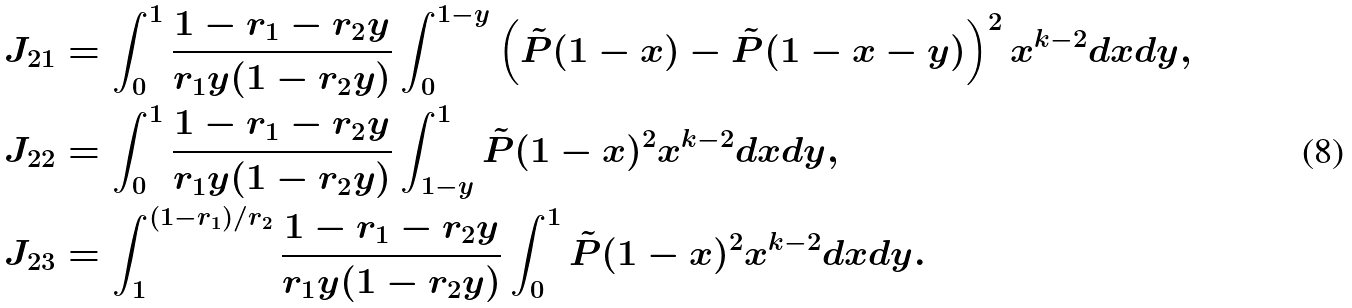Convert formula to latex. <formula><loc_0><loc_0><loc_500><loc_500>J _ { 2 1 } & = \int _ { 0 } ^ { 1 } \frac { 1 - r _ { 1 } - r _ { 2 } y } { r _ { 1 } y ( 1 - r _ { 2 } y ) } \int _ { 0 } ^ { 1 - y } \left ( \tilde { P } ( 1 - x ) - \tilde { P } ( 1 - x - y ) \right ) ^ { 2 } x ^ { k - 2 } d x d y , \\ J _ { 2 2 } & = \int _ { 0 } ^ { 1 } \frac { 1 - r _ { 1 } - r _ { 2 } y } { r _ { 1 } y ( 1 - r _ { 2 } y ) } \int _ { 1 - y } ^ { 1 } \tilde { P } ( 1 - x ) ^ { 2 } x ^ { k - 2 } d x d y , \\ J _ { 2 3 } & = \int _ { 1 } ^ { ( 1 - r _ { 1 } ) / r _ { 2 } } \frac { 1 - r _ { 1 } - r _ { 2 } y } { r _ { 1 } y ( 1 - r _ { 2 } y ) } \int _ { 0 } ^ { 1 } \tilde { P } ( 1 - x ) ^ { 2 } x ^ { k - 2 } d x d y .</formula> 